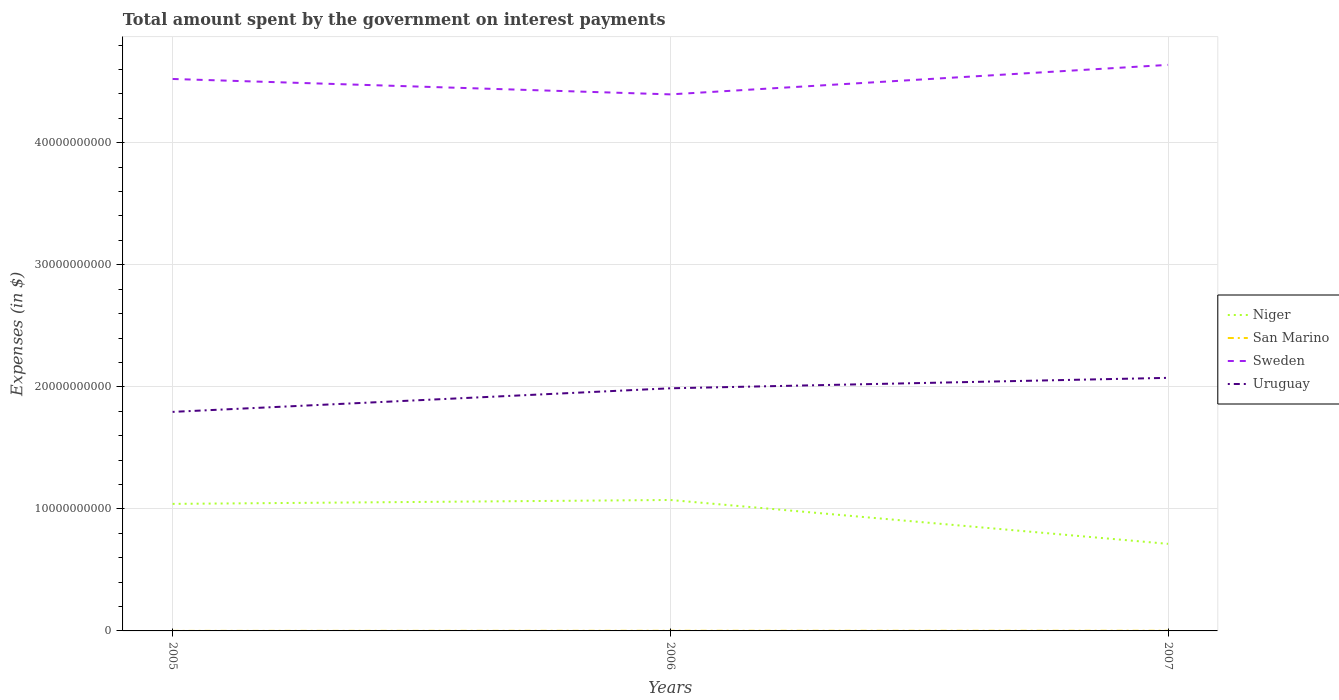Is the number of lines equal to the number of legend labels?
Offer a terse response. Yes. Across all years, what is the maximum amount spent on interest payments by the government in San Marino?
Keep it short and to the point. 2.77e+06. What is the total amount spent on interest payments by the government in Niger in the graph?
Your answer should be very brief. -3.18e+08. What is the difference between the highest and the second highest amount spent on interest payments by the government in Sweden?
Ensure brevity in your answer.  2.42e+09. How many years are there in the graph?
Keep it short and to the point. 3. What is the difference between two consecutive major ticks on the Y-axis?
Give a very brief answer. 1.00e+1. How are the legend labels stacked?
Your answer should be compact. Vertical. What is the title of the graph?
Provide a succinct answer. Total amount spent by the government on interest payments. What is the label or title of the X-axis?
Make the answer very short. Years. What is the label or title of the Y-axis?
Your response must be concise. Expenses (in $). What is the Expenses (in $) of Niger in 2005?
Ensure brevity in your answer.  1.04e+1. What is the Expenses (in $) of San Marino in 2005?
Offer a terse response. 2.77e+06. What is the Expenses (in $) of Sweden in 2005?
Make the answer very short. 4.52e+1. What is the Expenses (in $) in Uruguay in 2005?
Offer a very short reply. 1.79e+1. What is the Expenses (in $) of Niger in 2006?
Provide a short and direct response. 1.07e+1. What is the Expenses (in $) of San Marino in 2006?
Ensure brevity in your answer.  1.10e+07. What is the Expenses (in $) of Sweden in 2006?
Make the answer very short. 4.40e+1. What is the Expenses (in $) in Uruguay in 2006?
Your answer should be compact. 1.99e+1. What is the Expenses (in $) of Niger in 2007?
Give a very brief answer. 7.13e+09. What is the Expenses (in $) of San Marino in 2007?
Make the answer very short. 1.27e+07. What is the Expenses (in $) in Sweden in 2007?
Your answer should be compact. 4.64e+1. What is the Expenses (in $) in Uruguay in 2007?
Ensure brevity in your answer.  2.07e+1. Across all years, what is the maximum Expenses (in $) in Niger?
Your answer should be very brief. 1.07e+1. Across all years, what is the maximum Expenses (in $) in San Marino?
Your response must be concise. 1.27e+07. Across all years, what is the maximum Expenses (in $) in Sweden?
Offer a terse response. 4.64e+1. Across all years, what is the maximum Expenses (in $) in Uruguay?
Provide a succinct answer. 2.07e+1. Across all years, what is the minimum Expenses (in $) of Niger?
Your answer should be very brief. 7.13e+09. Across all years, what is the minimum Expenses (in $) of San Marino?
Ensure brevity in your answer.  2.77e+06. Across all years, what is the minimum Expenses (in $) in Sweden?
Ensure brevity in your answer.  4.40e+1. Across all years, what is the minimum Expenses (in $) in Uruguay?
Ensure brevity in your answer.  1.79e+1. What is the total Expenses (in $) in Niger in the graph?
Give a very brief answer. 2.83e+1. What is the total Expenses (in $) in San Marino in the graph?
Provide a succinct answer. 2.65e+07. What is the total Expenses (in $) of Sweden in the graph?
Provide a succinct answer. 1.36e+11. What is the total Expenses (in $) of Uruguay in the graph?
Provide a short and direct response. 5.86e+1. What is the difference between the Expenses (in $) in Niger in 2005 and that in 2006?
Provide a succinct answer. -3.18e+08. What is the difference between the Expenses (in $) in San Marino in 2005 and that in 2006?
Keep it short and to the point. -8.20e+06. What is the difference between the Expenses (in $) in Sweden in 2005 and that in 2006?
Offer a very short reply. 1.26e+09. What is the difference between the Expenses (in $) in Uruguay in 2005 and that in 2006?
Give a very brief answer. -1.93e+09. What is the difference between the Expenses (in $) in Niger in 2005 and that in 2007?
Your answer should be compact. 3.28e+09. What is the difference between the Expenses (in $) in San Marino in 2005 and that in 2007?
Make the answer very short. -9.97e+06. What is the difference between the Expenses (in $) in Sweden in 2005 and that in 2007?
Offer a very short reply. -1.16e+09. What is the difference between the Expenses (in $) of Uruguay in 2005 and that in 2007?
Offer a very short reply. -2.79e+09. What is the difference between the Expenses (in $) in Niger in 2006 and that in 2007?
Your answer should be very brief. 3.59e+09. What is the difference between the Expenses (in $) in San Marino in 2006 and that in 2007?
Ensure brevity in your answer.  -1.77e+06. What is the difference between the Expenses (in $) in Sweden in 2006 and that in 2007?
Give a very brief answer. -2.42e+09. What is the difference between the Expenses (in $) in Uruguay in 2006 and that in 2007?
Your response must be concise. -8.55e+08. What is the difference between the Expenses (in $) of Niger in 2005 and the Expenses (in $) of San Marino in 2006?
Provide a succinct answer. 1.04e+1. What is the difference between the Expenses (in $) in Niger in 2005 and the Expenses (in $) in Sweden in 2006?
Offer a terse response. -3.36e+1. What is the difference between the Expenses (in $) of Niger in 2005 and the Expenses (in $) of Uruguay in 2006?
Give a very brief answer. -9.47e+09. What is the difference between the Expenses (in $) in San Marino in 2005 and the Expenses (in $) in Sweden in 2006?
Offer a terse response. -4.40e+1. What is the difference between the Expenses (in $) of San Marino in 2005 and the Expenses (in $) of Uruguay in 2006?
Give a very brief answer. -1.99e+1. What is the difference between the Expenses (in $) of Sweden in 2005 and the Expenses (in $) of Uruguay in 2006?
Your response must be concise. 2.53e+1. What is the difference between the Expenses (in $) in Niger in 2005 and the Expenses (in $) in San Marino in 2007?
Your answer should be compact. 1.04e+1. What is the difference between the Expenses (in $) of Niger in 2005 and the Expenses (in $) of Sweden in 2007?
Provide a succinct answer. -3.60e+1. What is the difference between the Expenses (in $) in Niger in 2005 and the Expenses (in $) in Uruguay in 2007?
Give a very brief answer. -1.03e+1. What is the difference between the Expenses (in $) in San Marino in 2005 and the Expenses (in $) in Sweden in 2007?
Your answer should be very brief. -4.64e+1. What is the difference between the Expenses (in $) in San Marino in 2005 and the Expenses (in $) in Uruguay in 2007?
Your answer should be compact. -2.07e+1. What is the difference between the Expenses (in $) in Sweden in 2005 and the Expenses (in $) in Uruguay in 2007?
Ensure brevity in your answer.  2.45e+1. What is the difference between the Expenses (in $) of Niger in 2006 and the Expenses (in $) of San Marino in 2007?
Keep it short and to the point. 1.07e+1. What is the difference between the Expenses (in $) in Niger in 2006 and the Expenses (in $) in Sweden in 2007?
Give a very brief answer. -3.57e+1. What is the difference between the Expenses (in $) in Niger in 2006 and the Expenses (in $) in Uruguay in 2007?
Provide a short and direct response. -1.00e+1. What is the difference between the Expenses (in $) in San Marino in 2006 and the Expenses (in $) in Sweden in 2007?
Your answer should be compact. -4.64e+1. What is the difference between the Expenses (in $) in San Marino in 2006 and the Expenses (in $) in Uruguay in 2007?
Make the answer very short. -2.07e+1. What is the difference between the Expenses (in $) of Sweden in 2006 and the Expenses (in $) of Uruguay in 2007?
Make the answer very short. 2.32e+1. What is the average Expenses (in $) in Niger per year?
Your response must be concise. 9.42e+09. What is the average Expenses (in $) in San Marino per year?
Offer a terse response. 8.83e+06. What is the average Expenses (in $) in Sweden per year?
Your response must be concise. 4.52e+1. What is the average Expenses (in $) in Uruguay per year?
Keep it short and to the point. 1.95e+1. In the year 2005, what is the difference between the Expenses (in $) of Niger and Expenses (in $) of San Marino?
Your answer should be very brief. 1.04e+1. In the year 2005, what is the difference between the Expenses (in $) in Niger and Expenses (in $) in Sweden?
Give a very brief answer. -3.48e+1. In the year 2005, what is the difference between the Expenses (in $) of Niger and Expenses (in $) of Uruguay?
Provide a short and direct response. -7.54e+09. In the year 2005, what is the difference between the Expenses (in $) in San Marino and Expenses (in $) in Sweden?
Ensure brevity in your answer.  -4.52e+1. In the year 2005, what is the difference between the Expenses (in $) of San Marino and Expenses (in $) of Uruguay?
Offer a terse response. -1.79e+1. In the year 2005, what is the difference between the Expenses (in $) of Sweden and Expenses (in $) of Uruguay?
Your response must be concise. 2.73e+1. In the year 2006, what is the difference between the Expenses (in $) in Niger and Expenses (in $) in San Marino?
Give a very brief answer. 1.07e+1. In the year 2006, what is the difference between the Expenses (in $) in Niger and Expenses (in $) in Sweden?
Offer a very short reply. -3.32e+1. In the year 2006, what is the difference between the Expenses (in $) of Niger and Expenses (in $) of Uruguay?
Provide a short and direct response. -9.15e+09. In the year 2006, what is the difference between the Expenses (in $) of San Marino and Expenses (in $) of Sweden?
Your answer should be very brief. -4.40e+1. In the year 2006, what is the difference between the Expenses (in $) in San Marino and Expenses (in $) in Uruguay?
Give a very brief answer. -1.99e+1. In the year 2006, what is the difference between the Expenses (in $) of Sweden and Expenses (in $) of Uruguay?
Your response must be concise. 2.41e+1. In the year 2007, what is the difference between the Expenses (in $) in Niger and Expenses (in $) in San Marino?
Your answer should be compact. 7.12e+09. In the year 2007, what is the difference between the Expenses (in $) in Niger and Expenses (in $) in Sweden?
Make the answer very short. -3.92e+1. In the year 2007, what is the difference between the Expenses (in $) of Niger and Expenses (in $) of Uruguay?
Give a very brief answer. -1.36e+1. In the year 2007, what is the difference between the Expenses (in $) of San Marino and Expenses (in $) of Sweden?
Keep it short and to the point. -4.64e+1. In the year 2007, what is the difference between the Expenses (in $) of San Marino and Expenses (in $) of Uruguay?
Your response must be concise. -2.07e+1. In the year 2007, what is the difference between the Expenses (in $) of Sweden and Expenses (in $) of Uruguay?
Ensure brevity in your answer.  2.56e+1. What is the ratio of the Expenses (in $) of Niger in 2005 to that in 2006?
Make the answer very short. 0.97. What is the ratio of the Expenses (in $) in San Marino in 2005 to that in 2006?
Provide a short and direct response. 0.25. What is the ratio of the Expenses (in $) in Sweden in 2005 to that in 2006?
Make the answer very short. 1.03. What is the ratio of the Expenses (in $) of Uruguay in 2005 to that in 2006?
Offer a terse response. 0.9. What is the ratio of the Expenses (in $) in Niger in 2005 to that in 2007?
Provide a short and direct response. 1.46. What is the ratio of the Expenses (in $) of San Marino in 2005 to that in 2007?
Give a very brief answer. 0.22. What is the ratio of the Expenses (in $) in Sweden in 2005 to that in 2007?
Offer a very short reply. 0.98. What is the ratio of the Expenses (in $) in Uruguay in 2005 to that in 2007?
Your response must be concise. 0.87. What is the ratio of the Expenses (in $) in Niger in 2006 to that in 2007?
Provide a short and direct response. 1.5. What is the ratio of the Expenses (in $) in San Marino in 2006 to that in 2007?
Keep it short and to the point. 0.86. What is the ratio of the Expenses (in $) of Sweden in 2006 to that in 2007?
Give a very brief answer. 0.95. What is the ratio of the Expenses (in $) in Uruguay in 2006 to that in 2007?
Your response must be concise. 0.96. What is the difference between the highest and the second highest Expenses (in $) of Niger?
Offer a very short reply. 3.18e+08. What is the difference between the highest and the second highest Expenses (in $) in San Marino?
Your answer should be very brief. 1.77e+06. What is the difference between the highest and the second highest Expenses (in $) in Sweden?
Your response must be concise. 1.16e+09. What is the difference between the highest and the second highest Expenses (in $) in Uruguay?
Your answer should be very brief. 8.55e+08. What is the difference between the highest and the lowest Expenses (in $) in Niger?
Ensure brevity in your answer.  3.59e+09. What is the difference between the highest and the lowest Expenses (in $) of San Marino?
Your answer should be very brief. 9.97e+06. What is the difference between the highest and the lowest Expenses (in $) of Sweden?
Your answer should be compact. 2.42e+09. What is the difference between the highest and the lowest Expenses (in $) in Uruguay?
Provide a short and direct response. 2.79e+09. 